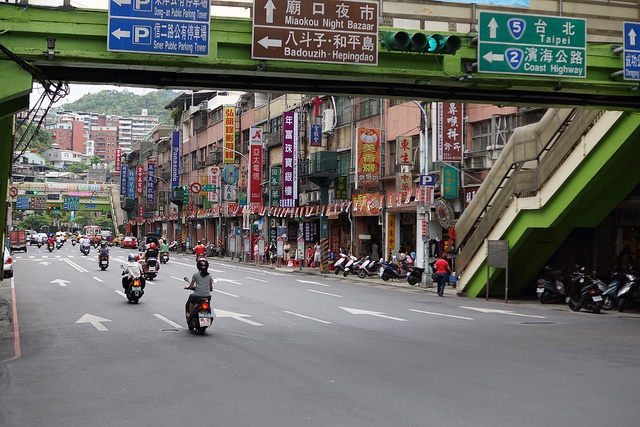Describe the objects in this image and their specific colors. I can see motorcycle in beige, black, gray, darkgray, and olive tones, people in beige, gray, black, darkgray, and lightgray tones, motorcycle in beige, black, gray, darkgray, and purple tones, people in beige, gray, black, darkgray, and maroon tones, and motorcycle in beige, black, darkgray, gray, and maroon tones in this image. 